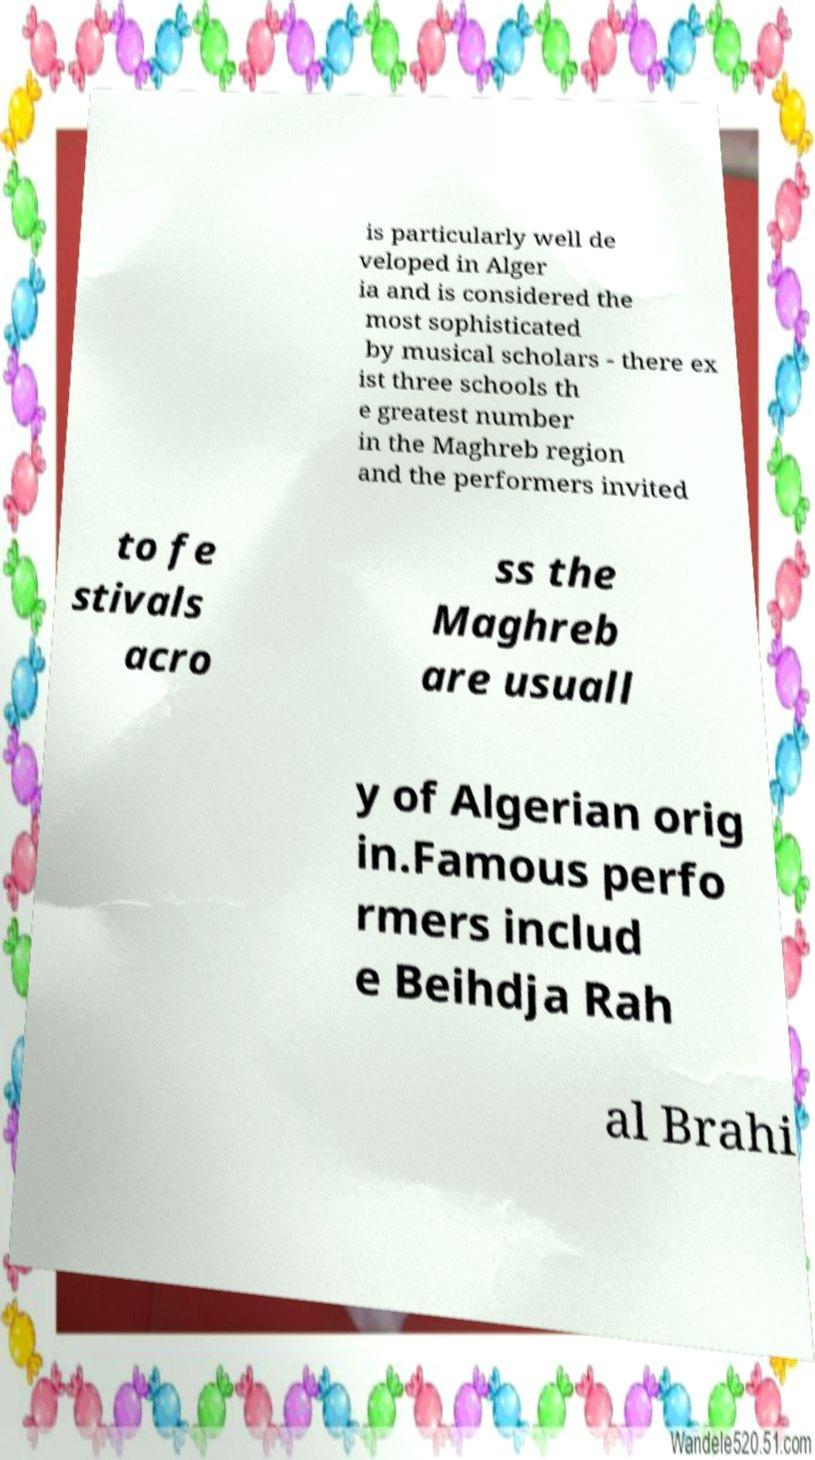Please identify and transcribe the text found in this image. is particularly well de veloped in Alger ia and is considered the most sophisticated by musical scholars - there ex ist three schools th e greatest number in the Maghreb region and the performers invited to fe stivals acro ss the Maghreb are usuall y of Algerian orig in.Famous perfo rmers includ e Beihdja Rah al Brahi 